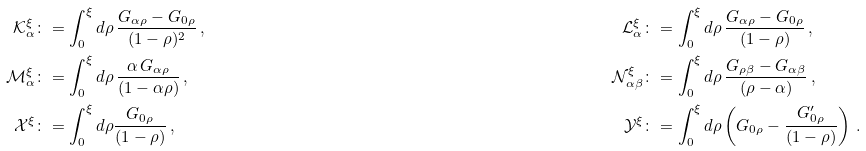<formula> <loc_0><loc_0><loc_500><loc_500>\mathcal { K } _ { \alpha } ^ { \xi } & \colon = \int _ { 0 } ^ { \xi } d \rho \, \frac { G _ { \alpha \rho } - G _ { 0 \rho } } { ( 1 - \rho ) ^ { 2 } } \, , & \mathcal { L } _ { \alpha } ^ { \xi } & \colon = \int _ { 0 } ^ { \xi } d \rho \, \frac { G _ { \alpha \rho } - G _ { 0 \rho } } { ( 1 - \rho ) } \, , \\ \mathcal { M } _ { \alpha } ^ { \xi } & \colon = \int _ { 0 } ^ { \xi } d \rho \, \frac { \alpha \, G _ { \alpha \rho } } { ( 1 - \alpha \rho ) } \, , & \mathcal { N } _ { \alpha \beta } ^ { \xi } & \colon = \int _ { 0 } ^ { \xi } d \rho \, \frac { G _ { \rho \beta } - G _ { \alpha \beta } } { ( \rho - \alpha ) } \, , \\ \mathcal { X } ^ { \xi } & \colon = \int _ { 0 } ^ { \xi } d \rho \frac { G _ { 0 \rho } } { ( 1 - \rho ) } \, , & \mathcal { Y } ^ { \xi } & \colon = \int _ { 0 } ^ { \xi } d \rho \left ( G _ { 0 \rho } - \frac { G ^ { \prime } _ { 0 \rho } } { ( 1 - \rho ) } \right ) \, .</formula> 